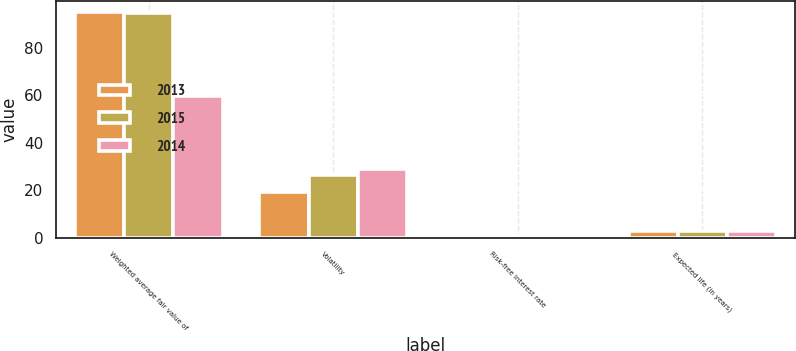Convert chart to OTSL. <chart><loc_0><loc_0><loc_500><loc_500><stacked_bar_chart><ecel><fcel>Weighted average fair value of<fcel>Volatility<fcel>Risk-free interest rate<fcel>Expected life (in years)<nl><fcel>2013<fcel>95.07<fcel>19.14<fcel>1.01<fcel>2.86<nl><fcel>2015<fcel>94.55<fcel>26.41<fcel>0.65<fcel>2.88<nl><fcel>2014<fcel>59.58<fcel>28.99<fcel>0.4<fcel>2.87<nl></chart> 